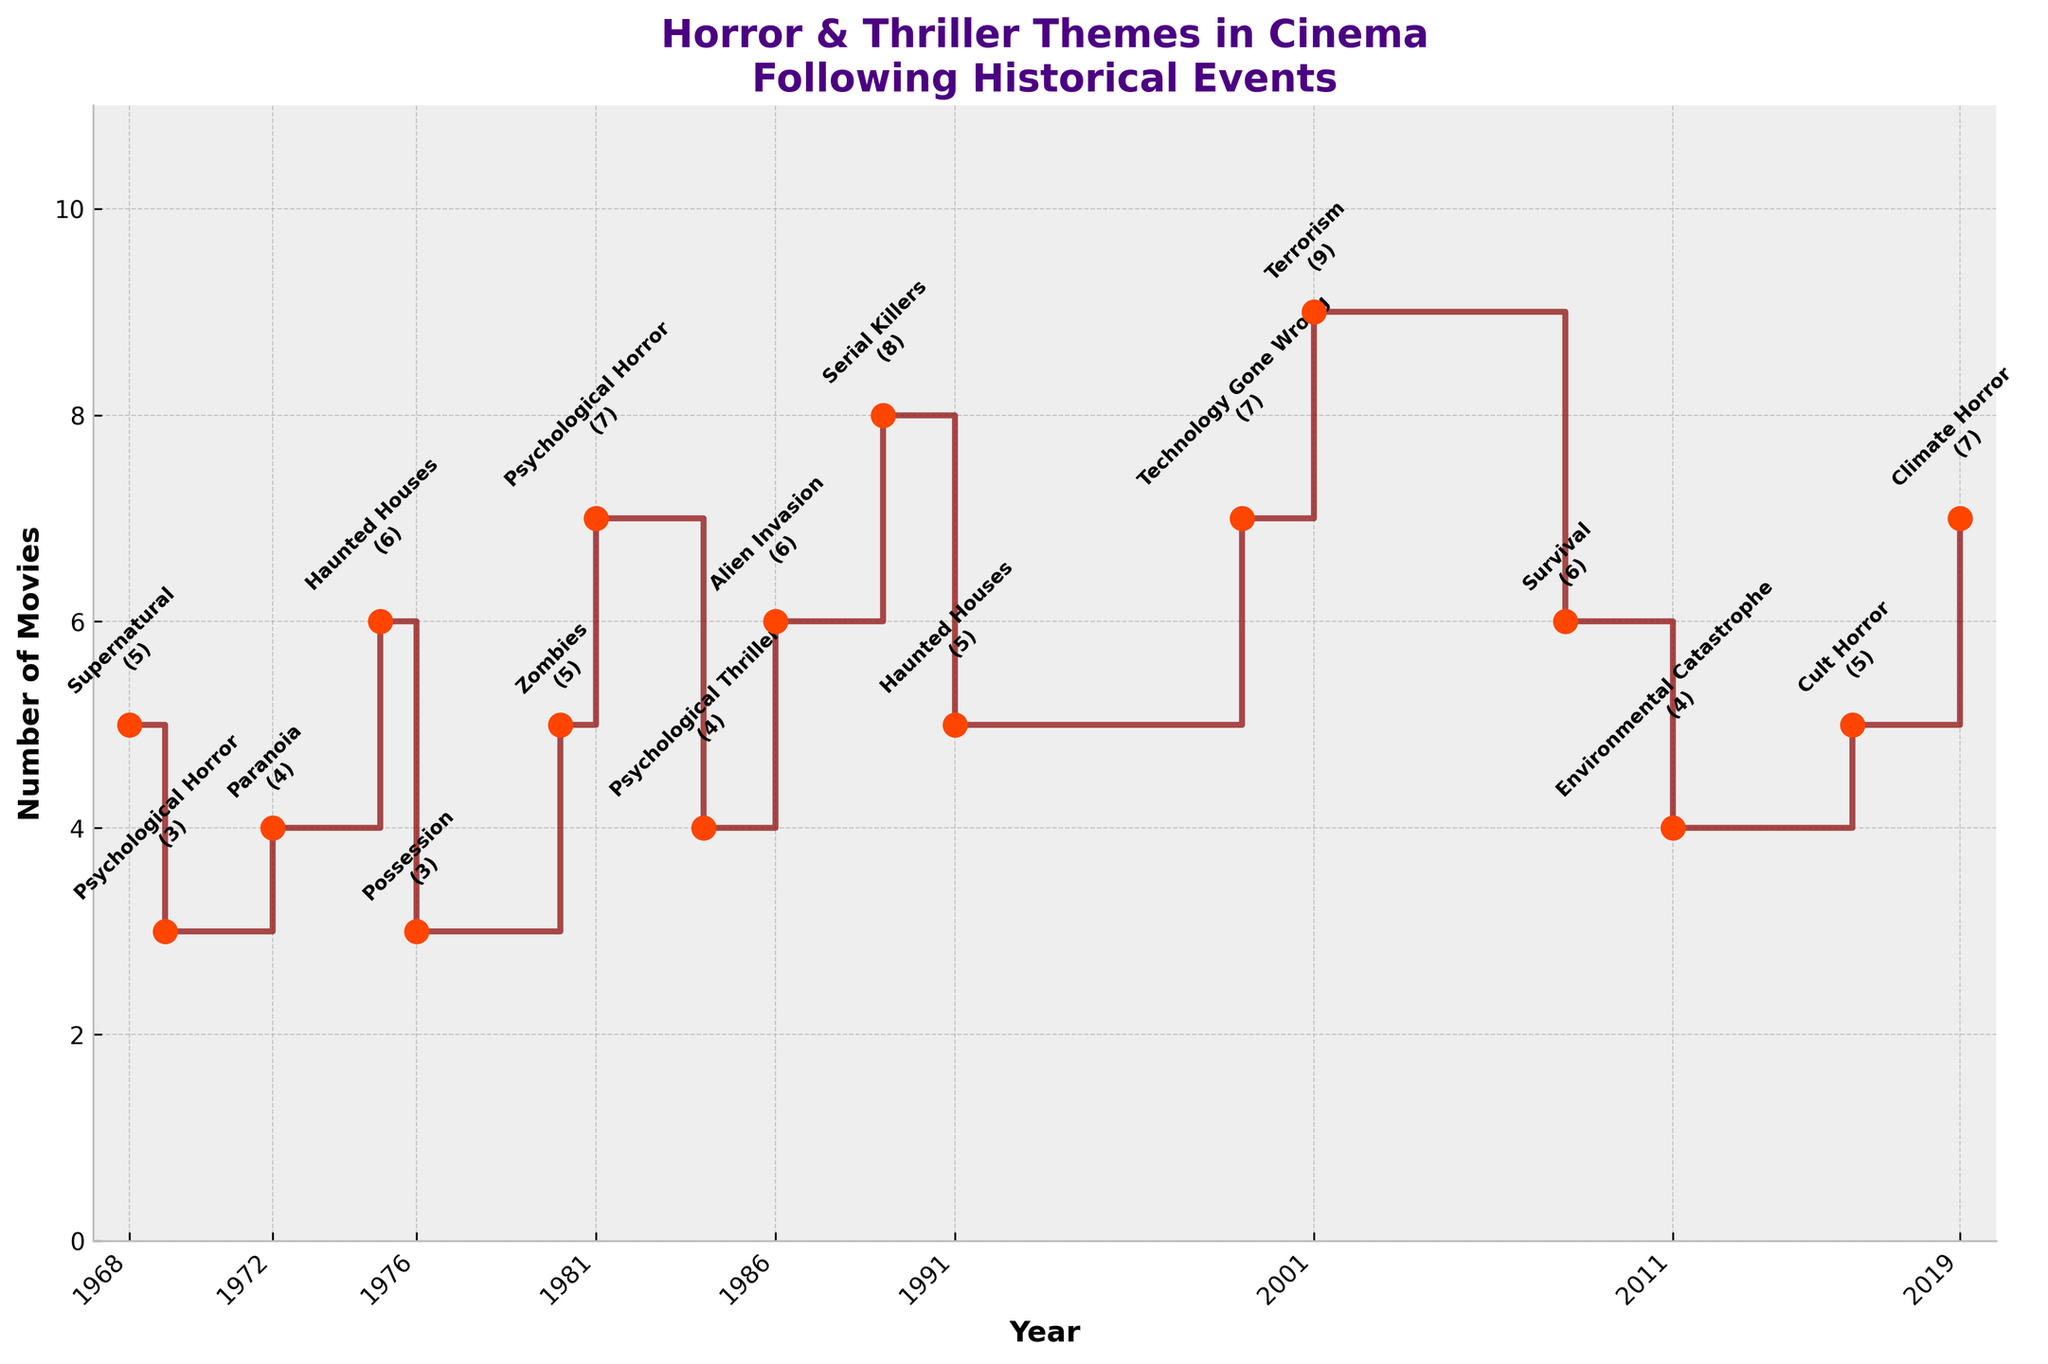what is the title of the figure? The title of a plot is typically displayed at the top. In this figure, it is located centrally and reads: "Horror & Thriller Themes in Cinema Following Historical Events".
Answer: Horror & Thriller Themes in Cinema Following Historical Events How many movies with the theme "Terrorism" were there in 2001? To find out how many movies had the "Terrorism" theme in 2001, you can look for the year 2001 on the x-axis and then check the corresponding value on the y-axis. The figure also includes annotations next to the points providing the value directly, which in this case is 9.
Answer: 9 Which historical event had the most number of movies themed around "Climate Horror"? Look for the theme "Climate Horror" in the annotations, then find the corresponding historical event and the number of movies associated with it. This theme appears in 2019, during the Global Climate Protests with 7 movies.
Answer: Global Climate Protests What is the difference in the number of movies between the themes "Supernatural" in 1968 and "Psychological Horror" in 1969? Locate the number of movies for "Supernatural" in 1968 and "Psychological Horror" in 1969 through the annotations next to the points. "Supernatural" has 5 movies and "Psychological Horror" has 3 movies. The difference is 5 - 3 = 2.
Answer: 2 How many themes have an odd number of movies associated with them? Count the annotations to find themes with an odd number of movies: "Supernatural" (5), "Psychological Horror" (3), "Zombies" (5), "Psychological Thriller" (4), "Serial Killers" (8), "Technology Gone Wrong" (7), "Terrorism" (9), "Cult Horror" (5), "Climate Horror" (7). The count is 8 themes.
Answer: 8 Which year had the highest number of horror and thriller-themed movies? Check the y-axis values and annotations to identify which year has the highest number of movies. "Terrorism" in 2001 has the highest number with 9 movies.
Answer: 2001 How many movies were produced combined for the themes "Haunted Houses" in 1975 and 1991? Find the number of movies for "Haunted Houses" in both 1975 and 1991 from their respective annotations: 6 in 1975 and 5 in 1991. Add them together: 6 + 5 = 11.
Answer: 11 Which two themes had the same number of movies produced in their respective years, and what is that number? Look for annotations indicating the same number of movies across different years. Both "Psychological Horror" in 1981 and "Climate Horror" in 2019 had 7 movies each.
Answer: Psychological Horror and Climate Horror, 7 